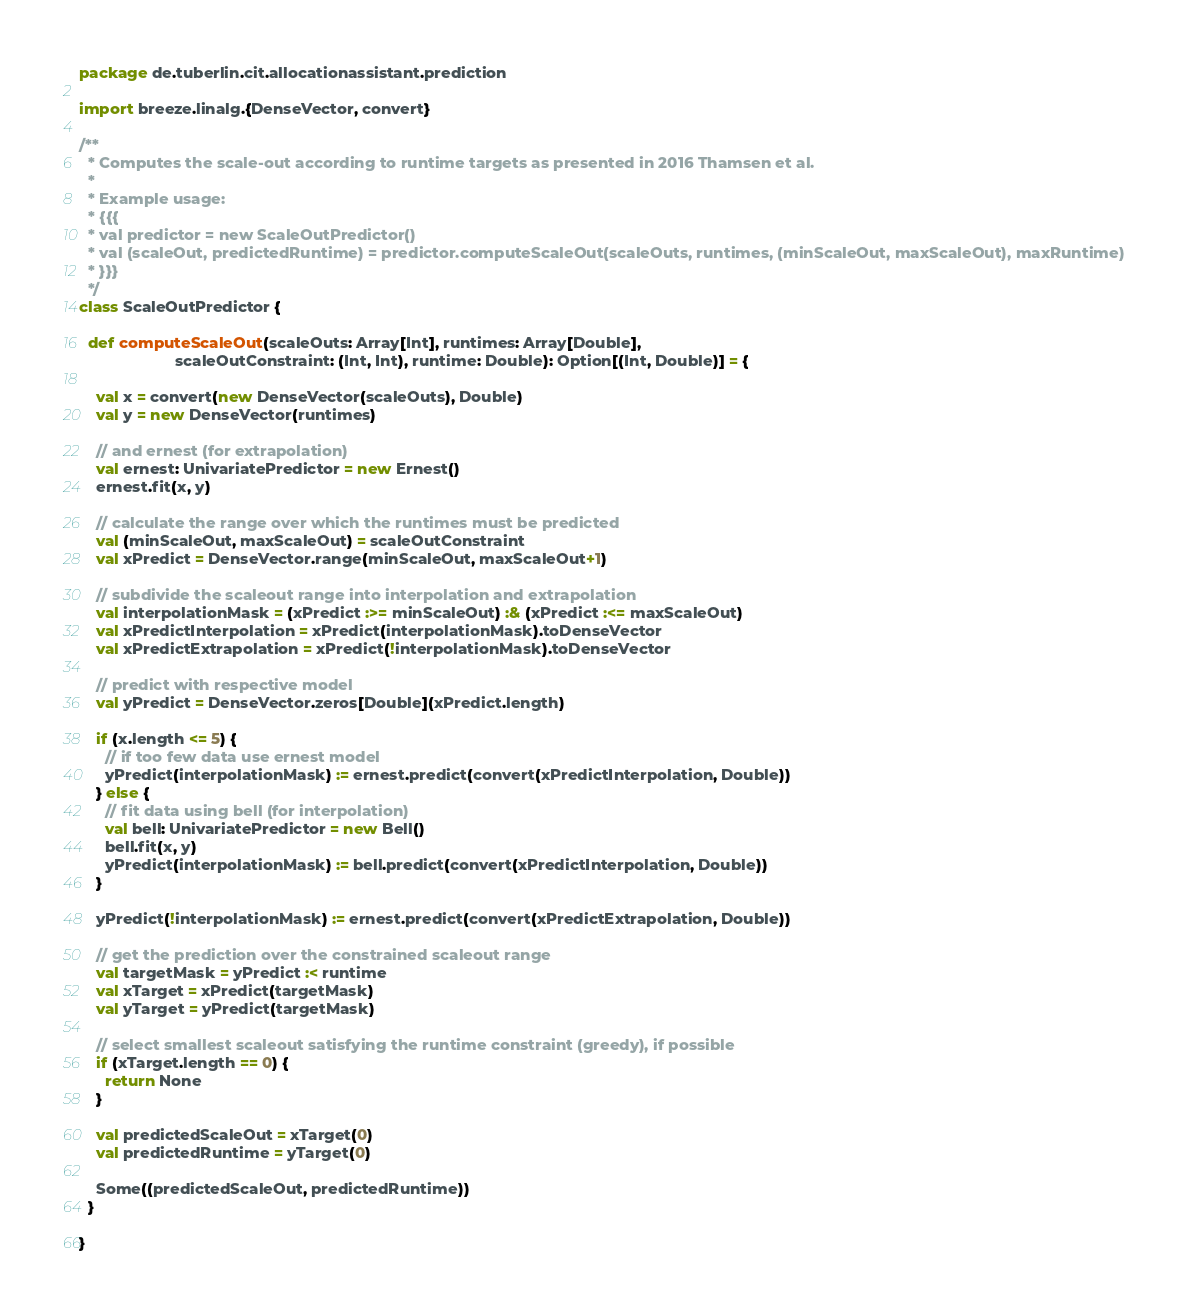Convert code to text. <code><loc_0><loc_0><loc_500><loc_500><_Scala_>package de.tuberlin.cit.allocationassistant.prediction

import breeze.linalg.{DenseVector, convert}

/**
  * Computes the scale-out according to runtime targets as presented in 2016 Thamsen et al.
  *
  * Example usage:
  * {{{
  * val predictor = new ScaleOutPredictor()
  * val (scaleOut, predictedRuntime) = predictor.computeScaleOut(scaleOuts, runtimes, (minScaleOut, maxScaleOut), maxRuntime)
  * }}}
  */
class ScaleOutPredictor {

  def computeScaleOut(scaleOuts: Array[Int], runtimes: Array[Double],
                      scaleOutConstraint: (Int, Int), runtime: Double): Option[(Int, Double)] = {

    val x = convert(new DenseVector(scaleOuts), Double)
    val y = new DenseVector(runtimes)

    // and ernest (for extrapolation)
    val ernest: UnivariatePredictor = new Ernest()
    ernest.fit(x, y)

    // calculate the range over which the runtimes must be predicted
    val (minScaleOut, maxScaleOut) = scaleOutConstraint
    val xPredict = DenseVector.range(minScaleOut, maxScaleOut+1)

    // subdivide the scaleout range into interpolation and extrapolation
    val interpolationMask = (xPredict :>= minScaleOut) :& (xPredict :<= maxScaleOut)
    val xPredictInterpolation = xPredict(interpolationMask).toDenseVector
    val xPredictExtrapolation = xPredict(!interpolationMask).toDenseVector

    // predict with respective model
    val yPredict = DenseVector.zeros[Double](xPredict.length)

    if (x.length <= 5) {
      // if too few data use ernest model
      yPredict(interpolationMask) := ernest.predict(convert(xPredictInterpolation, Double))
    } else {
      // fit data using bell (for interpolation)
      val bell: UnivariatePredictor = new Bell()
      bell.fit(x, y)
      yPredict(interpolationMask) := bell.predict(convert(xPredictInterpolation, Double))
    }

    yPredict(!interpolationMask) := ernest.predict(convert(xPredictExtrapolation, Double))

    // get the prediction over the constrained scaleout range
    val targetMask = yPredict :< runtime
    val xTarget = xPredict(targetMask)
    val yTarget = yPredict(targetMask)

    // select smallest scaleout satisfying the runtime constraint (greedy), if possible
    if (xTarget.length == 0) {
      return None
    }

    val predictedScaleOut = xTarget(0)
    val predictedRuntime = yTarget(0)

    Some((predictedScaleOut, predictedRuntime))
  }

}
</code> 